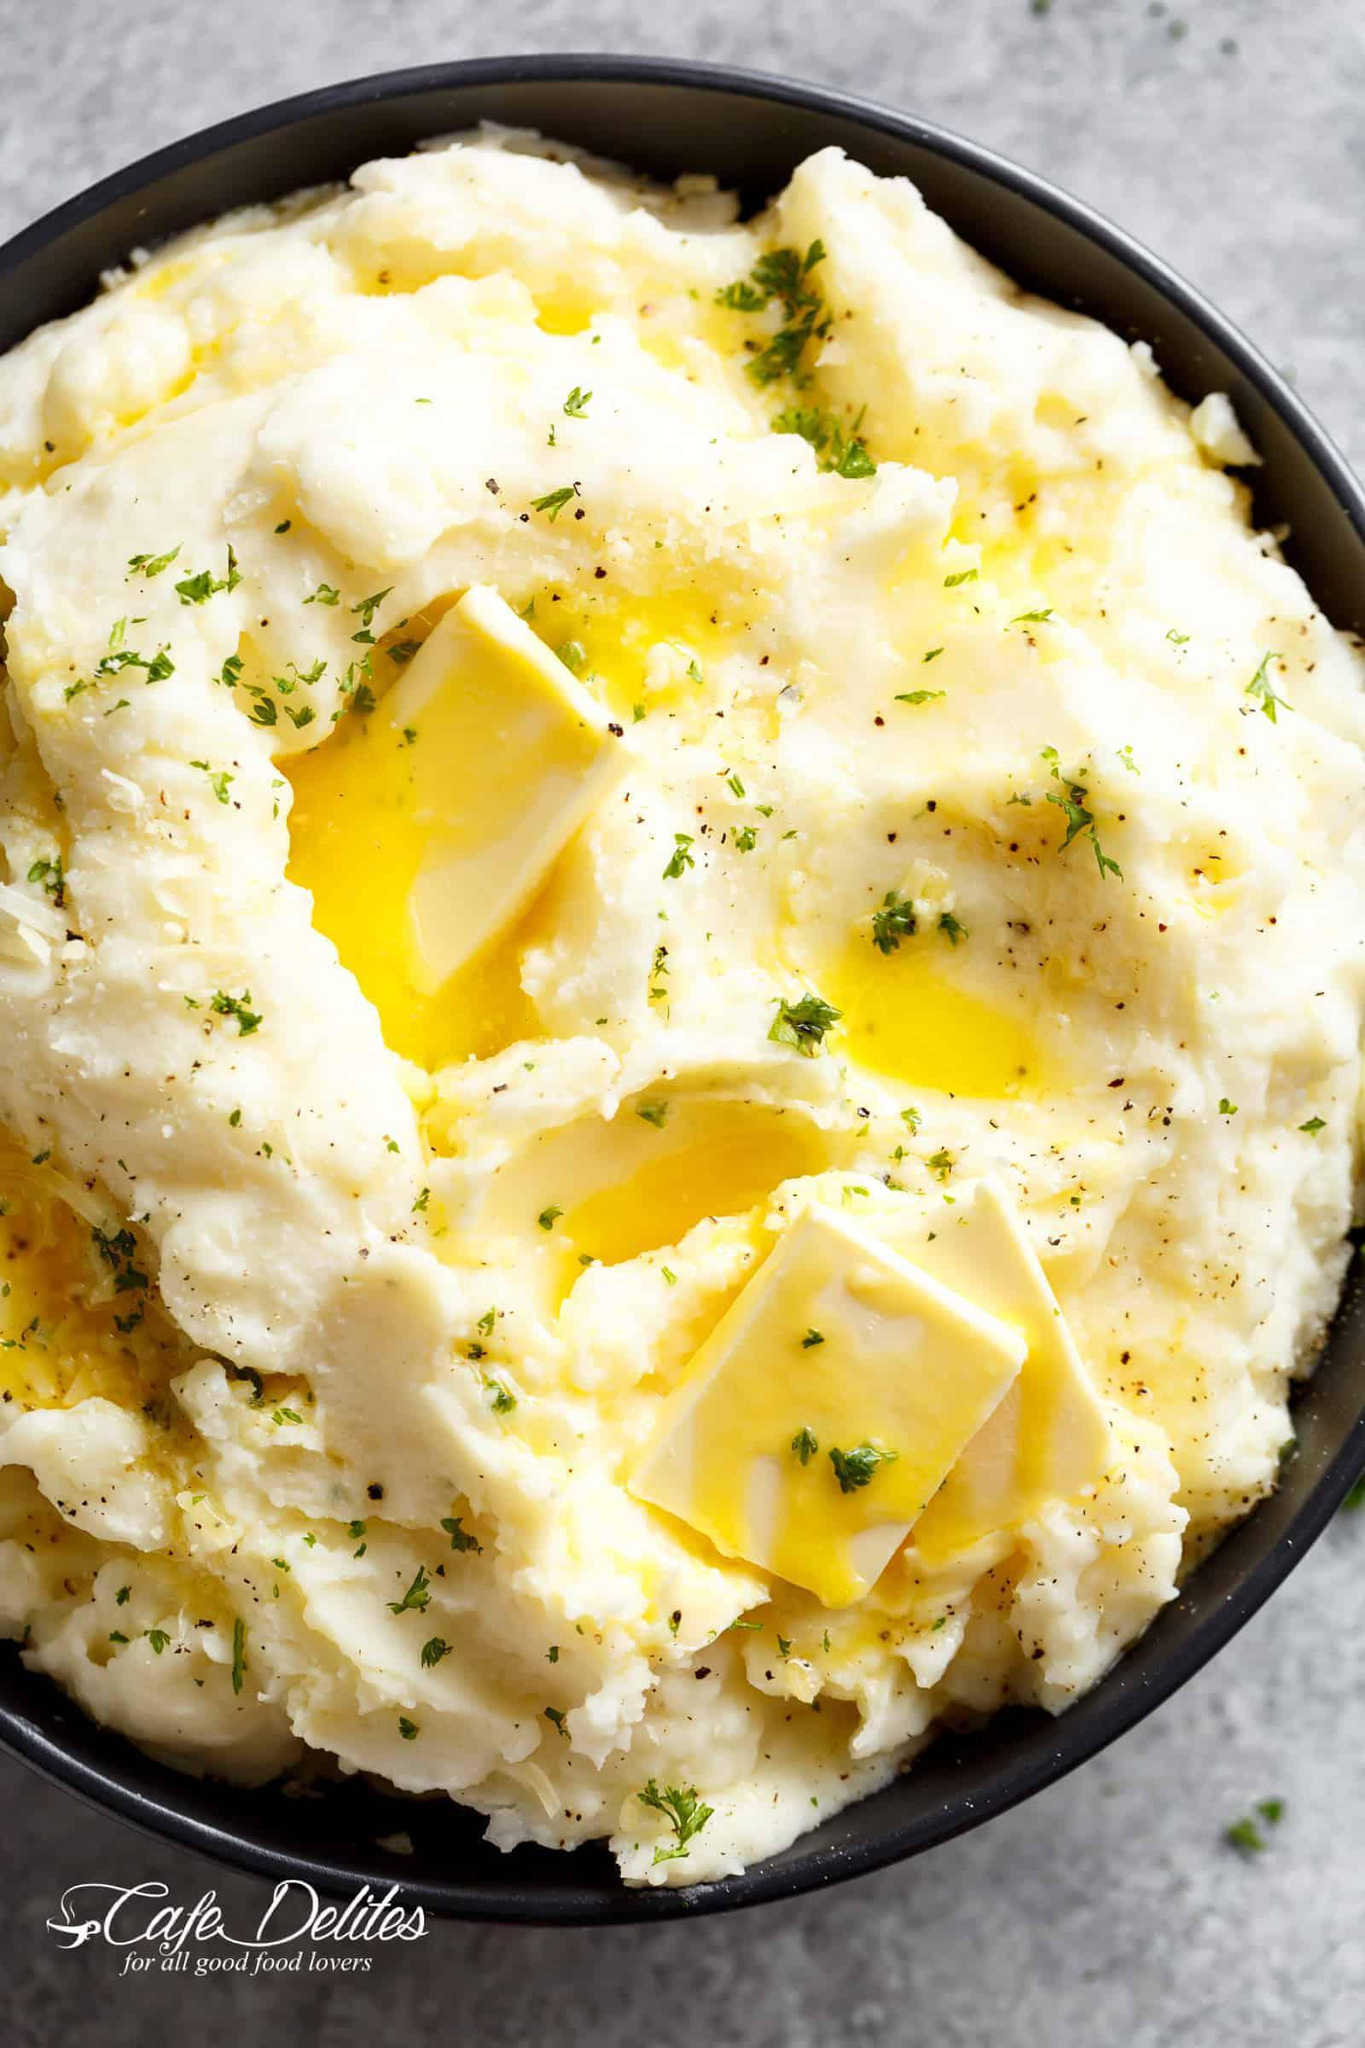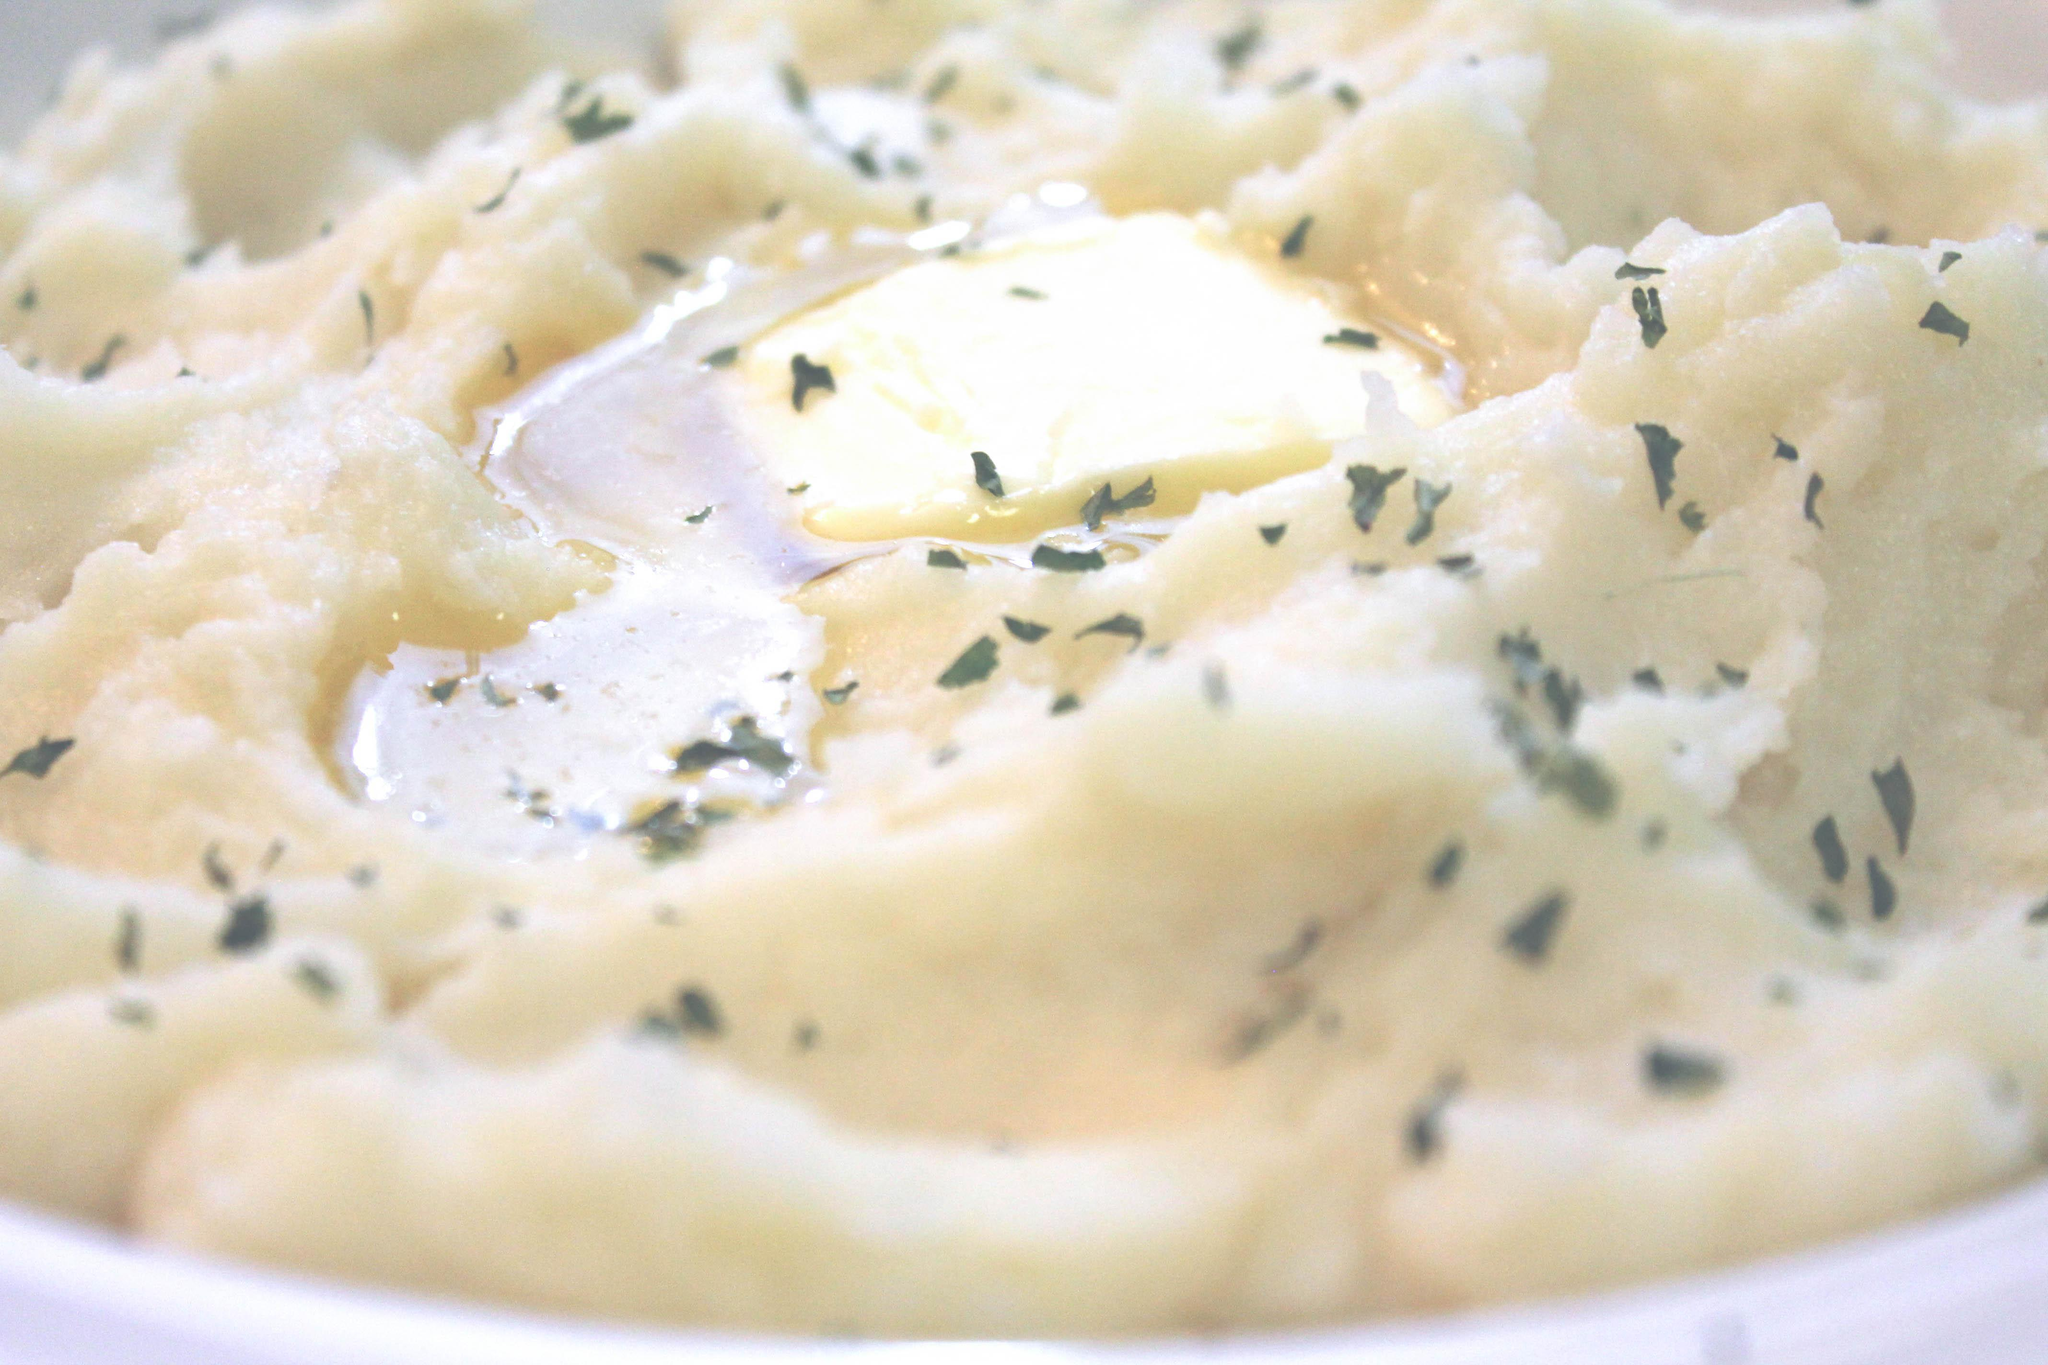The first image is the image on the left, the second image is the image on the right. Given the left and right images, does the statement "The left image shows mashed potatoes with no green garnish while the other serving is topped with greens." hold true? Answer yes or no. No. The first image is the image on the left, the second image is the image on the right. Examine the images to the left and right. Is the description "The left and right image contains the same number of mash potatoes and chive bowls." accurate? Answer yes or no. Yes. 